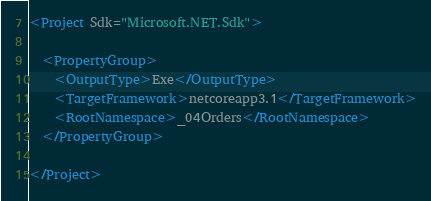<code> <loc_0><loc_0><loc_500><loc_500><_XML_><Project Sdk="Microsoft.NET.Sdk">

  <PropertyGroup>
    <OutputType>Exe</OutputType>
    <TargetFramework>netcoreapp3.1</TargetFramework>
    <RootNamespace>_04Orders</RootNamespace>
  </PropertyGroup>

</Project>
</code> 